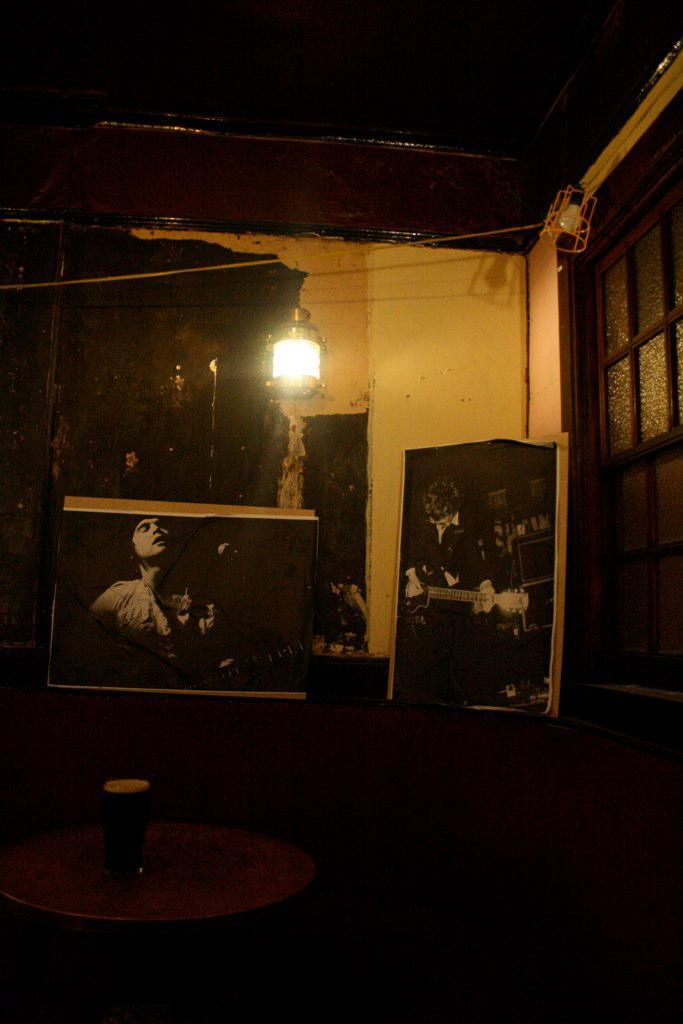What objects are present in the image that have a frame? There are frames in the image. What type of structure can be seen in the image? There is a wall in the image. What can be seen providing illumination in the image? There are lights in the image. What architectural feature is visible in the image that allows for natural light? There are windows in the image. What object is on a table in the image? There is a glass on a table in the image. How would you describe the overall lighting in the image? The image is dark. How many pigs are playing on the playground in the image? There are no pigs or playground present in the image. What type of trip is being taken in the image? There is no trip or indication of travel in the image. 